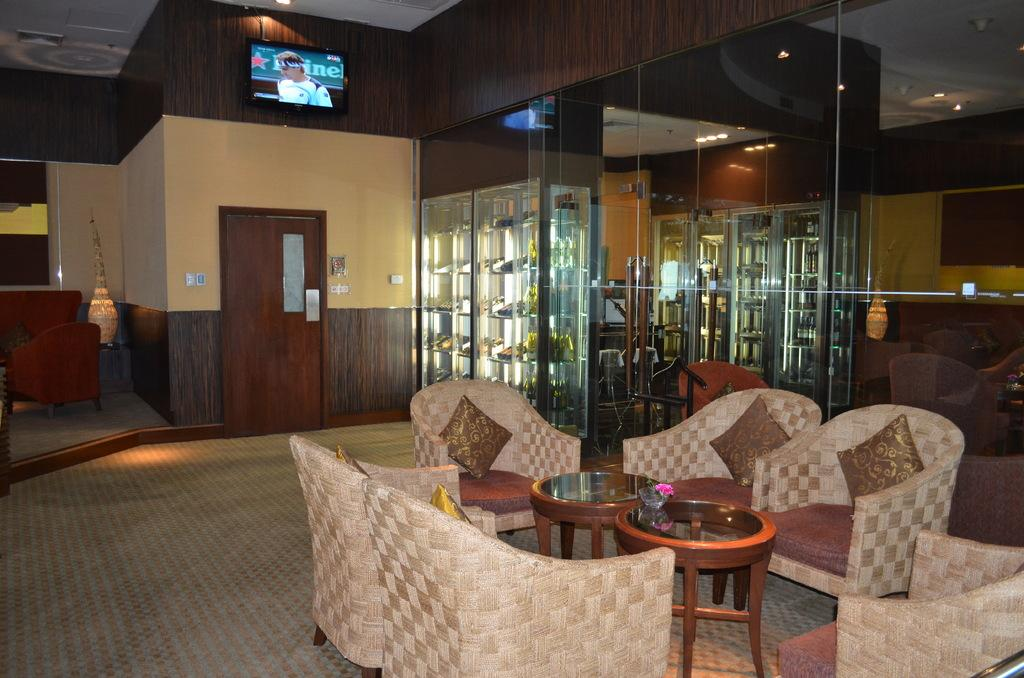What type of seating is present in the image? There is a couch and chairs in the image. What can be found on the seating for comfort or decoration? There are pillows in the image. What is the primary piece of furniture in the room? There is a table in the image. What is placed on the table? There is a bowl in the image. What type of decoration is present in the image? There is a flower in the image. What is used for storing items in the image? There is a rack in the image. What provides illumination in the image? There is a lamp in the image. What allows access to other areas in the image? There is a door in the image. What type of entertainment device is present in the image? There is a television in the image. What provides light in the room in the image? There are lights in the image. What is used to cover the floor in the image? There is a carpet in the image. How many cats are sitting on the couch in the image? There are no cats present in the image. What type of metal is used to make the lamp in the image? The type of metal used to make the lamp is not mentioned in the image. 